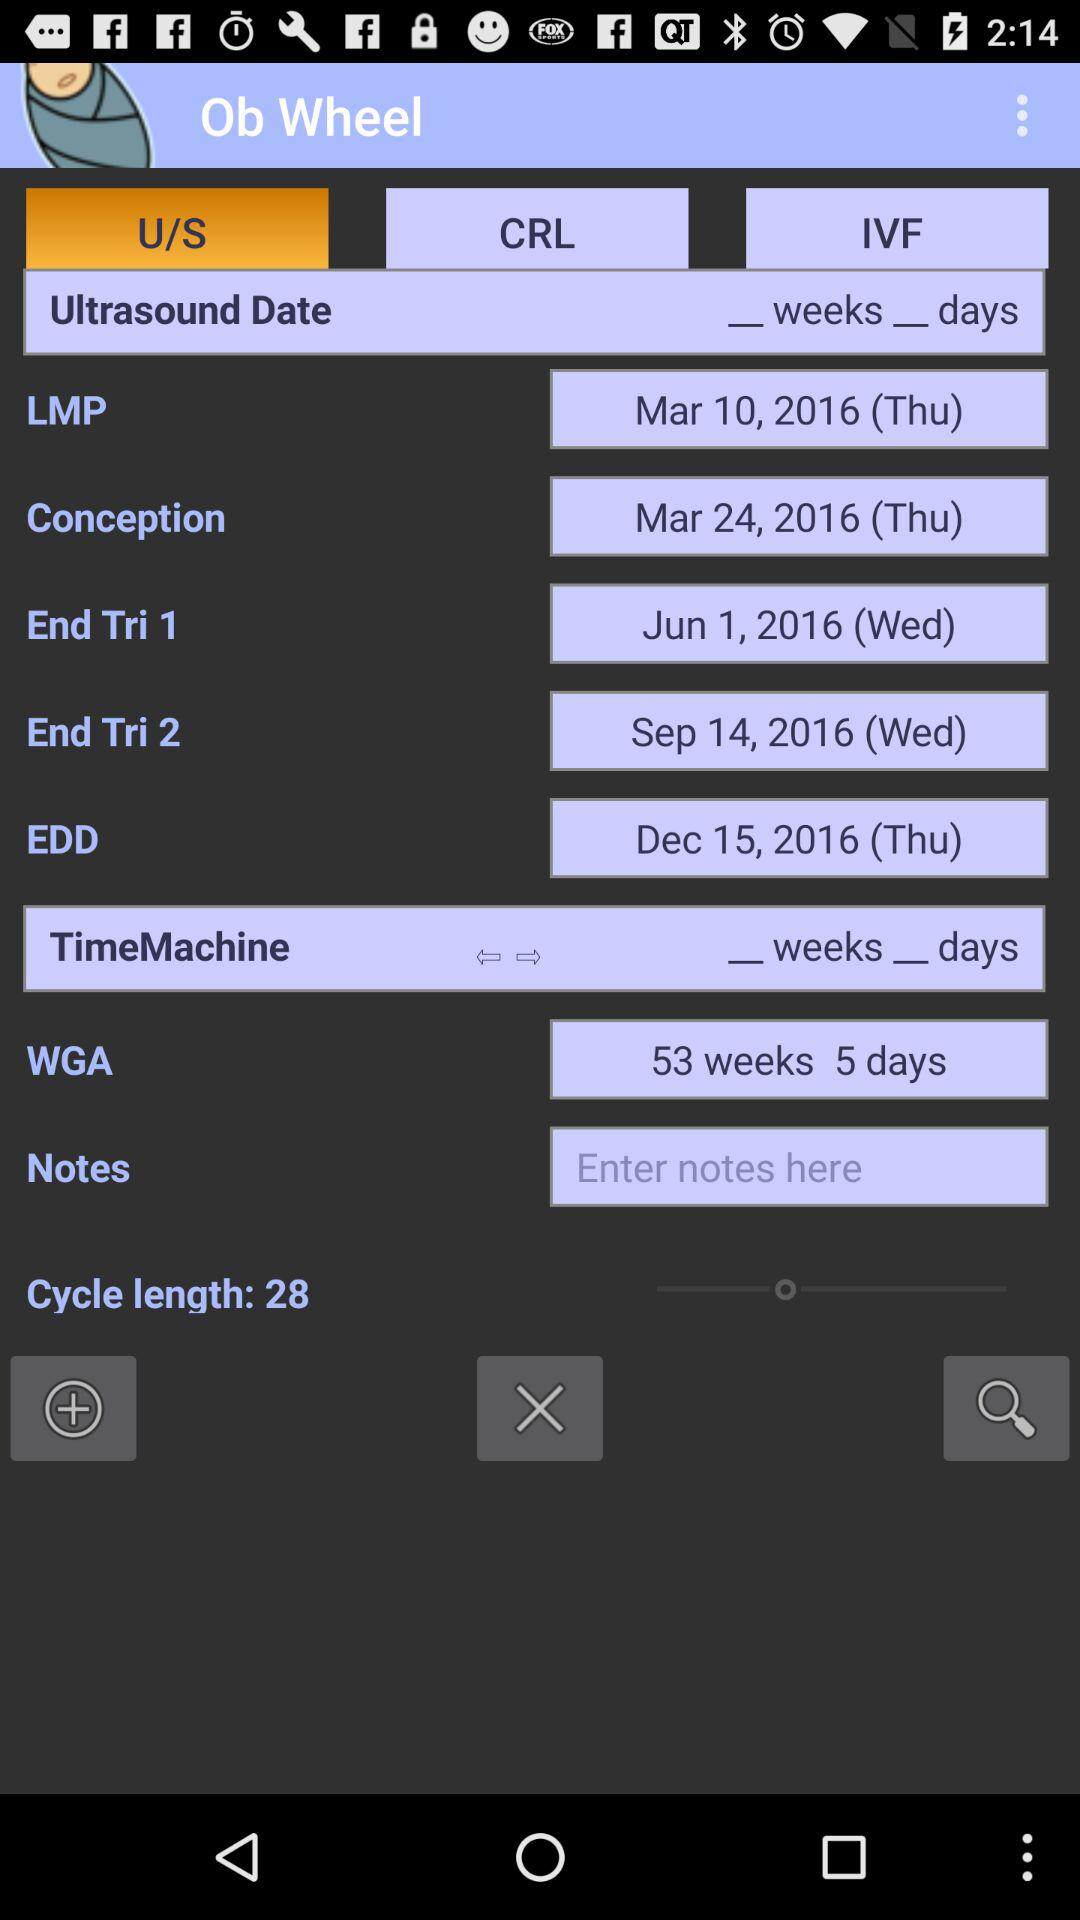How many days apart are the LMP and Conception dates?
Answer the question using a single word or phrase. 14 days 